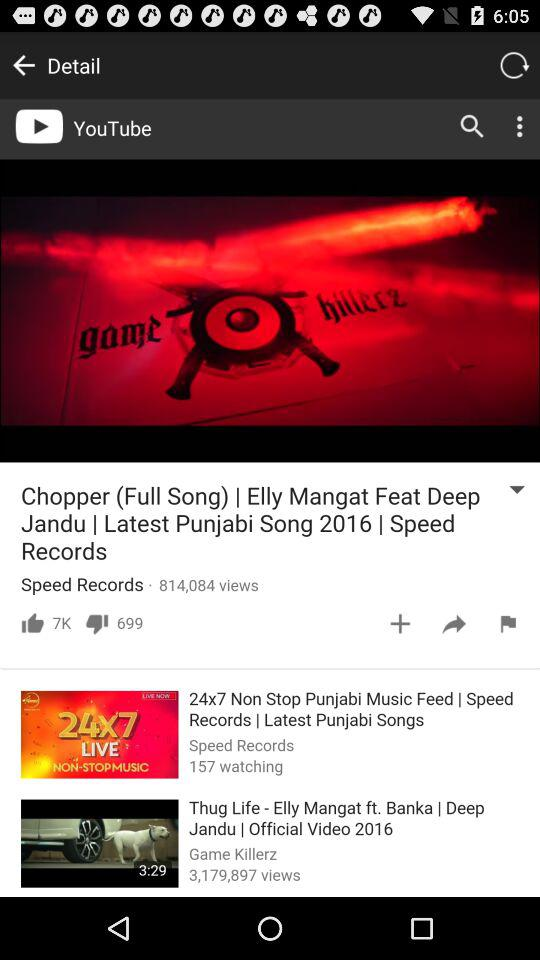On which channel was the video "Thug Life" uploaded? The video "Thug Life" was uploaded on the "Game Killerz" channel. 